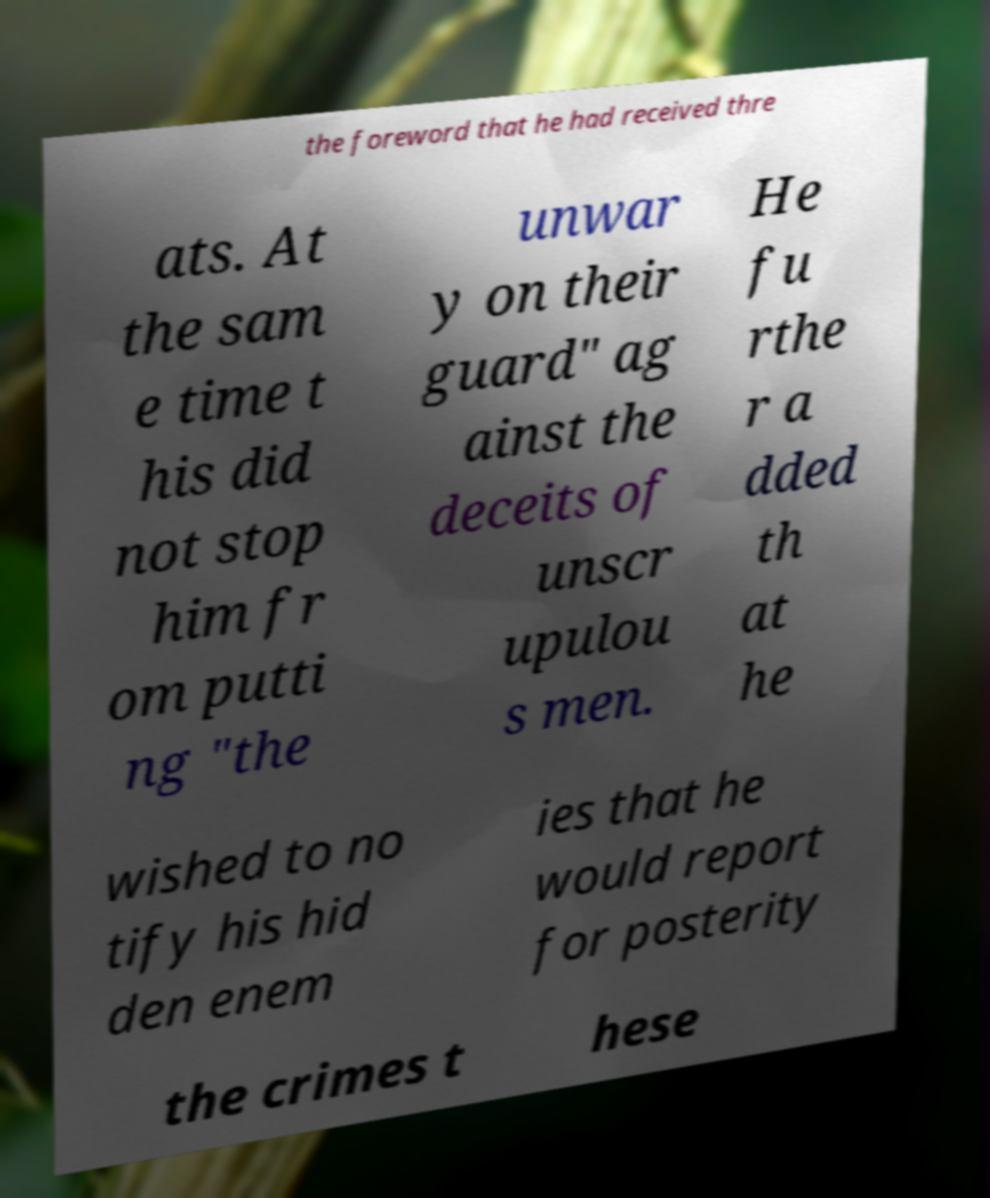I need the written content from this picture converted into text. Can you do that? the foreword that he had received thre ats. At the sam e time t his did not stop him fr om putti ng "the unwar y on their guard" ag ainst the deceits of unscr upulou s men. He fu rthe r a dded th at he wished to no tify his hid den enem ies that he would report for posterity the crimes t hese 